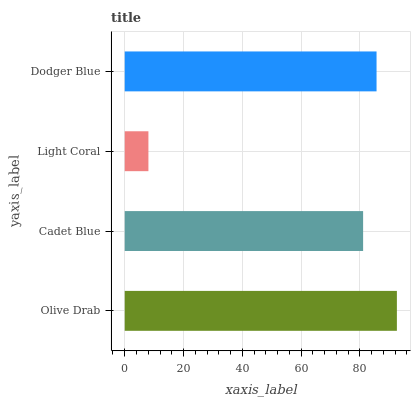Is Light Coral the minimum?
Answer yes or no. Yes. Is Olive Drab the maximum?
Answer yes or no. Yes. Is Cadet Blue the minimum?
Answer yes or no. No. Is Cadet Blue the maximum?
Answer yes or no. No. Is Olive Drab greater than Cadet Blue?
Answer yes or no. Yes. Is Cadet Blue less than Olive Drab?
Answer yes or no. Yes. Is Cadet Blue greater than Olive Drab?
Answer yes or no. No. Is Olive Drab less than Cadet Blue?
Answer yes or no. No. Is Dodger Blue the high median?
Answer yes or no. Yes. Is Cadet Blue the low median?
Answer yes or no. Yes. Is Cadet Blue the high median?
Answer yes or no. No. Is Dodger Blue the low median?
Answer yes or no. No. 